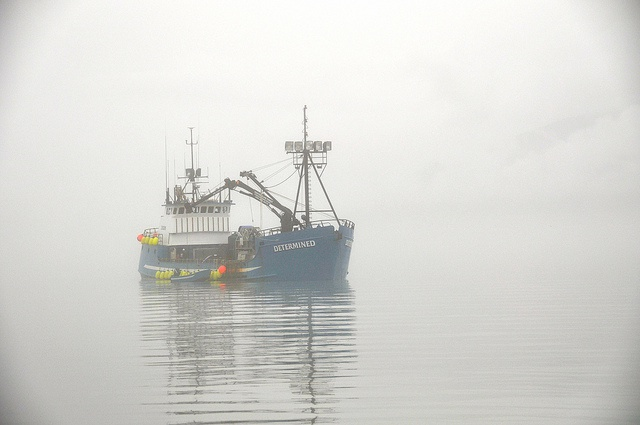Describe the objects in this image and their specific colors. I can see a boat in darkgray, lightgray, and gray tones in this image. 